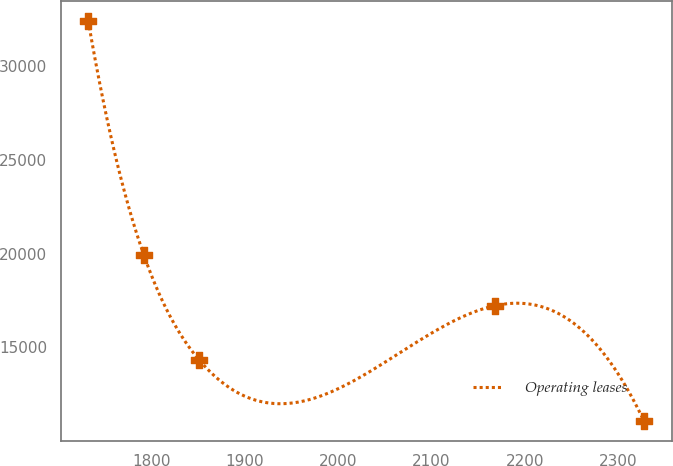Convert chart. <chart><loc_0><loc_0><loc_500><loc_500><line_chart><ecel><fcel>Operating leases<nl><fcel>1732.42<fcel>32394.8<nl><fcel>1791.95<fcel>19919.5<nl><fcel>1851.48<fcel>14303.5<nl><fcel>2168.3<fcel>17218.4<nl><fcel>2327.67<fcel>11075.6<nl></chart> 